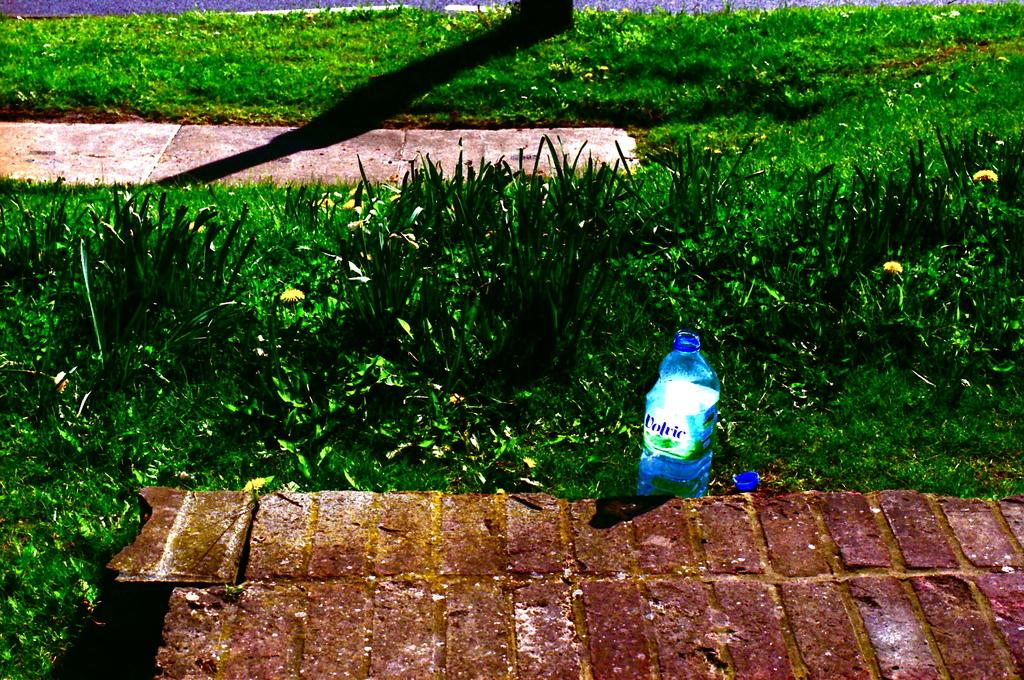What object can be found in the grass in the image? There is a bottle in the grass in the image. What other objects are present in the image? There are bricks in the image. Is there an umbrella being used to protect the bricks from an earthquake in the image? There is no umbrella or earthquake present in the image. Is there a horse interacting with the bricks in the image? There is no horse present in the image. 